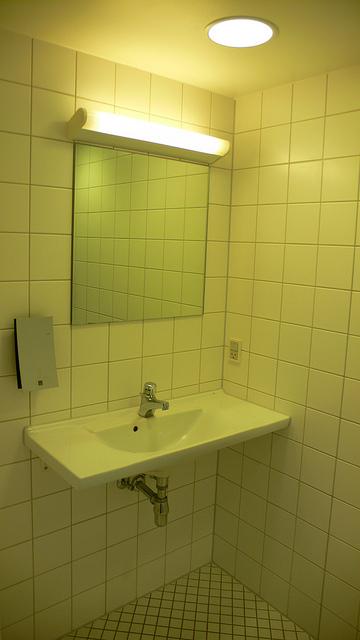What can you see in the mirror?
Give a very brief answer. Tile. What color are the tiles on the walls?
Write a very short answer. White. What type of room would this picture most likely be taken in?
Concise answer only. Bathroom. 